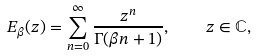Convert formula to latex. <formula><loc_0><loc_0><loc_500><loc_500>E _ { \beta } ( z ) = \sum _ { n = 0 } ^ { \infty } \frac { z ^ { n } } { \Gamma ( \beta n + 1 ) } , \quad z \in \mathbb { C } ,</formula> 